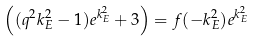Convert formula to latex. <formula><loc_0><loc_0><loc_500><loc_500>\left ( ( q ^ { 2 } k _ { E } ^ { 2 } - 1 ) e ^ { k _ { E } ^ { 2 } } + 3 \right ) = f ( - k _ { E } ^ { 2 } ) e ^ { k _ { E } ^ { 2 } }</formula> 